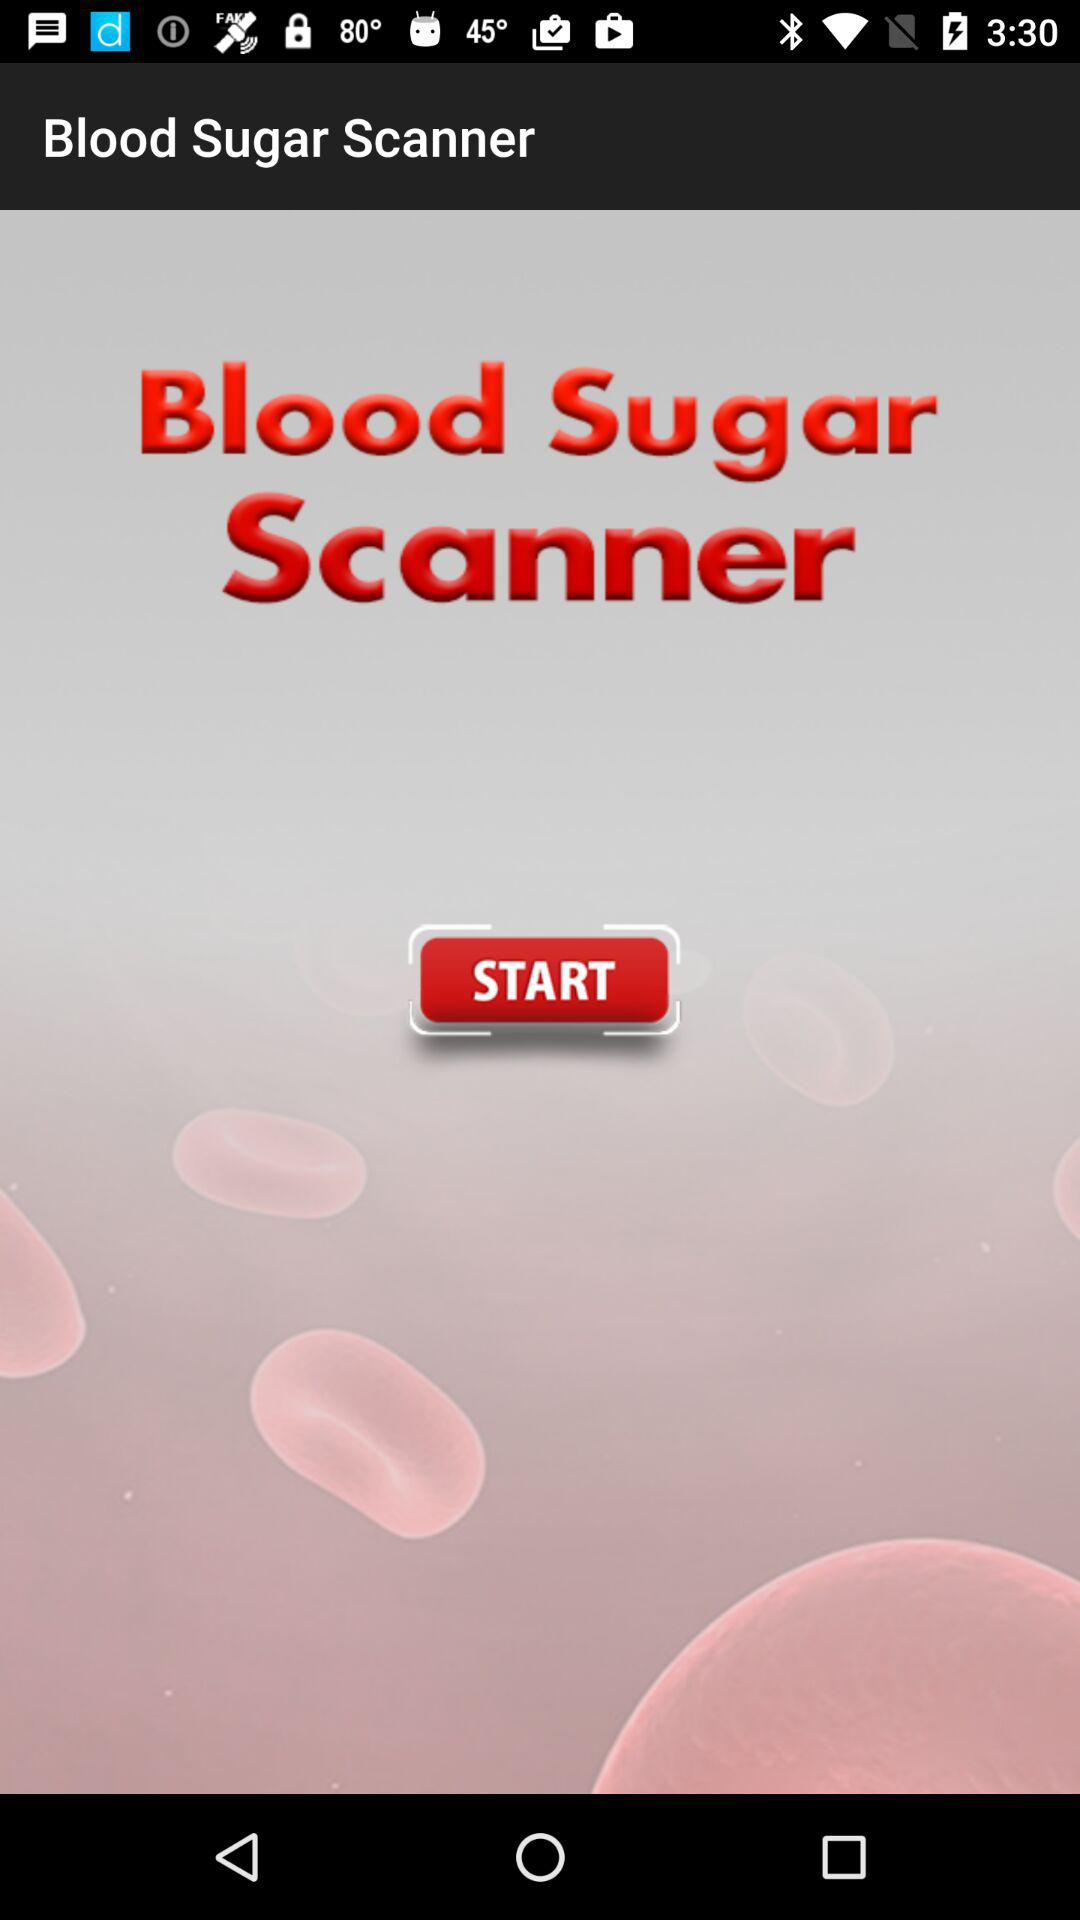What is the name of the application? The name of the application is "Blood Sugar Scanner". 